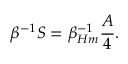Convert formula to latex. <formula><loc_0><loc_0><loc_500><loc_500>\beta ^ { - 1 } S = \beta _ { H m } ^ { - 1 } { \frac { A } { 4 } } .</formula> 